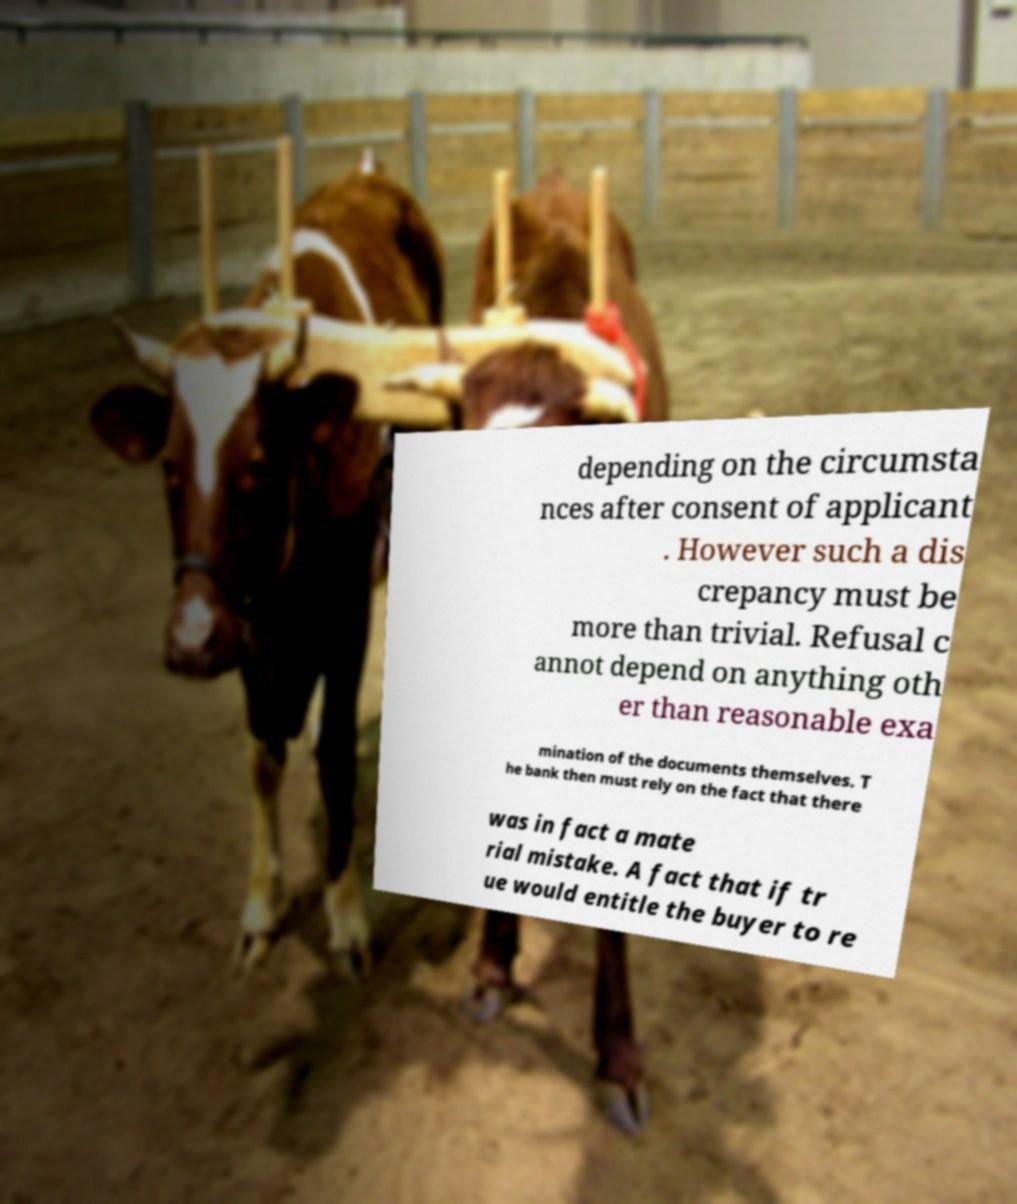What messages or text are displayed in this image? I need them in a readable, typed format. depending on the circumsta nces after consent of applicant . However such a dis crepancy must be more than trivial. Refusal c annot depend on anything oth er than reasonable exa mination of the documents themselves. T he bank then must rely on the fact that there was in fact a mate rial mistake. A fact that if tr ue would entitle the buyer to re 